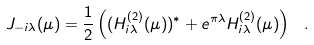<formula> <loc_0><loc_0><loc_500><loc_500>J _ { - i \lambda } ( \mu ) = \frac { 1 } { 2 } \left ( ( H _ { i \lambda } ^ { ( 2 ) } ( \mu ) ) ^ { * } + e ^ { \pi \lambda } H _ { i \lambda } ^ { ( 2 ) } ( \mu ) \right ) \ .</formula> 